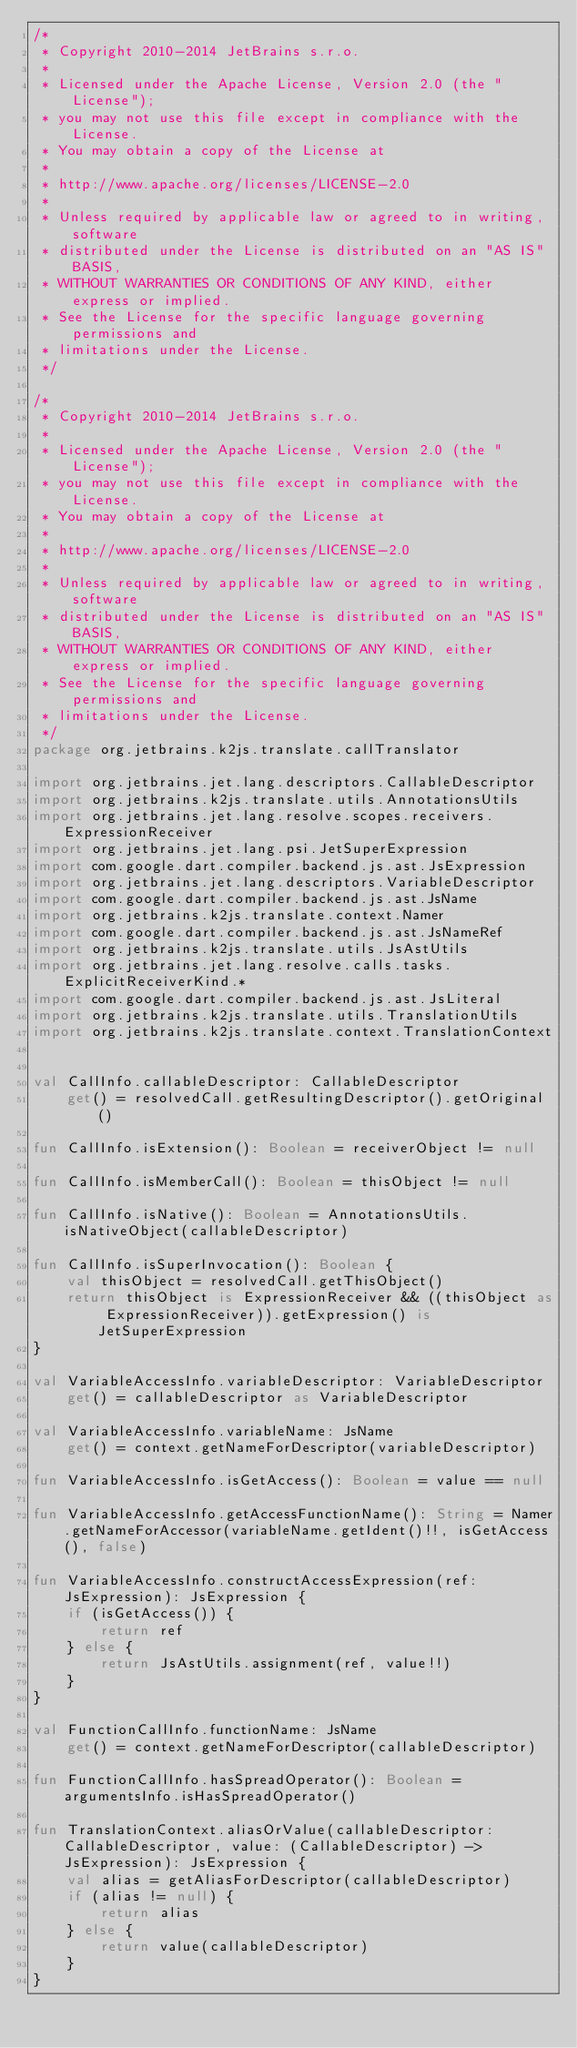Convert code to text. <code><loc_0><loc_0><loc_500><loc_500><_Kotlin_>/*
 * Copyright 2010-2014 JetBrains s.r.o.
 *
 * Licensed under the Apache License, Version 2.0 (the "License");
 * you may not use this file except in compliance with the License.
 * You may obtain a copy of the License at
 *
 * http://www.apache.org/licenses/LICENSE-2.0
 *
 * Unless required by applicable law or agreed to in writing, software
 * distributed under the License is distributed on an "AS IS" BASIS,
 * WITHOUT WARRANTIES OR CONDITIONS OF ANY KIND, either express or implied.
 * See the License for the specific language governing permissions and
 * limitations under the License.
 */

/*
 * Copyright 2010-2014 JetBrains s.r.o.
 *
 * Licensed under the Apache License, Version 2.0 (the "License");
 * you may not use this file except in compliance with the License.
 * You may obtain a copy of the License at
 *
 * http://www.apache.org/licenses/LICENSE-2.0
 *
 * Unless required by applicable law or agreed to in writing, software
 * distributed under the License is distributed on an "AS IS" BASIS,
 * WITHOUT WARRANTIES OR CONDITIONS OF ANY KIND, either express or implied.
 * See the License for the specific language governing permissions and
 * limitations under the License.
 */
package org.jetbrains.k2js.translate.callTranslator

import org.jetbrains.jet.lang.descriptors.CallableDescriptor
import org.jetbrains.k2js.translate.utils.AnnotationsUtils
import org.jetbrains.jet.lang.resolve.scopes.receivers.ExpressionReceiver
import org.jetbrains.jet.lang.psi.JetSuperExpression
import com.google.dart.compiler.backend.js.ast.JsExpression
import org.jetbrains.jet.lang.descriptors.VariableDescriptor
import com.google.dart.compiler.backend.js.ast.JsName
import org.jetbrains.k2js.translate.context.Namer
import com.google.dart.compiler.backend.js.ast.JsNameRef
import org.jetbrains.k2js.translate.utils.JsAstUtils
import org.jetbrains.jet.lang.resolve.calls.tasks.ExplicitReceiverKind.*
import com.google.dart.compiler.backend.js.ast.JsLiteral
import org.jetbrains.k2js.translate.utils.TranslationUtils
import org.jetbrains.k2js.translate.context.TranslationContext


val CallInfo.callableDescriptor: CallableDescriptor
    get() = resolvedCall.getResultingDescriptor().getOriginal()

fun CallInfo.isExtension(): Boolean = receiverObject != null

fun CallInfo.isMemberCall(): Boolean = thisObject != null

fun CallInfo.isNative(): Boolean = AnnotationsUtils.isNativeObject(callableDescriptor)

fun CallInfo.isSuperInvocation(): Boolean {
    val thisObject = resolvedCall.getThisObject()
    return thisObject is ExpressionReceiver && ((thisObject as ExpressionReceiver)).getExpression() is JetSuperExpression
}

val VariableAccessInfo.variableDescriptor: VariableDescriptor
    get() = callableDescriptor as VariableDescriptor

val VariableAccessInfo.variableName: JsName
    get() = context.getNameForDescriptor(variableDescriptor)

fun VariableAccessInfo.isGetAccess(): Boolean = value == null

fun VariableAccessInfo.getAccessFunctionName(): String = Namer.getNameForAccessor(variableName.getIdent()!!, isGetAccess(), false)

fun VariableAccessInfo.constructAccessExpression(ref: JsExpression): JsExpression {
    if (isGetAccess()) {
        return ref
    } else {
        return JsAstUtils.assignment(ref, value!!)
    }
}

val FunctionCallInfo.functionName: JsName
    get() = context.getNameForDescriptor(callableDescriptor)

fun FunctionCallInfo.hasSpreadOperator(): Boolean = argumentsInfo.isHasSpreadOperator()

fun TranslationContext.aliasOrValue(callableDescriptor: CallableDescriptor, value: (CallableDescriptor) -> JsExpression): JsExpression {
    val alias = getAliasForDescriptor(callableDescriptor)
    if (alias != null) {
        return alias
    } else {
        return value(callableDescriptor)
    }
}</code> 